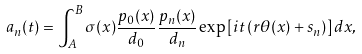<formula> <loc_0><loc_0><loc_500><loc_500>a _ { n } ( t ) = \int _ { A } ^ { B } \sigma ( x ) \frac { p _ { 0 } ( x ) } { d _ { 0 } } \frac { p _ { n } ( x ) } { d _ { n } } \exp \left [ i t \left ( r \theta ( x ) + s _ { n } \right ) \right ] d x ,</formula> 